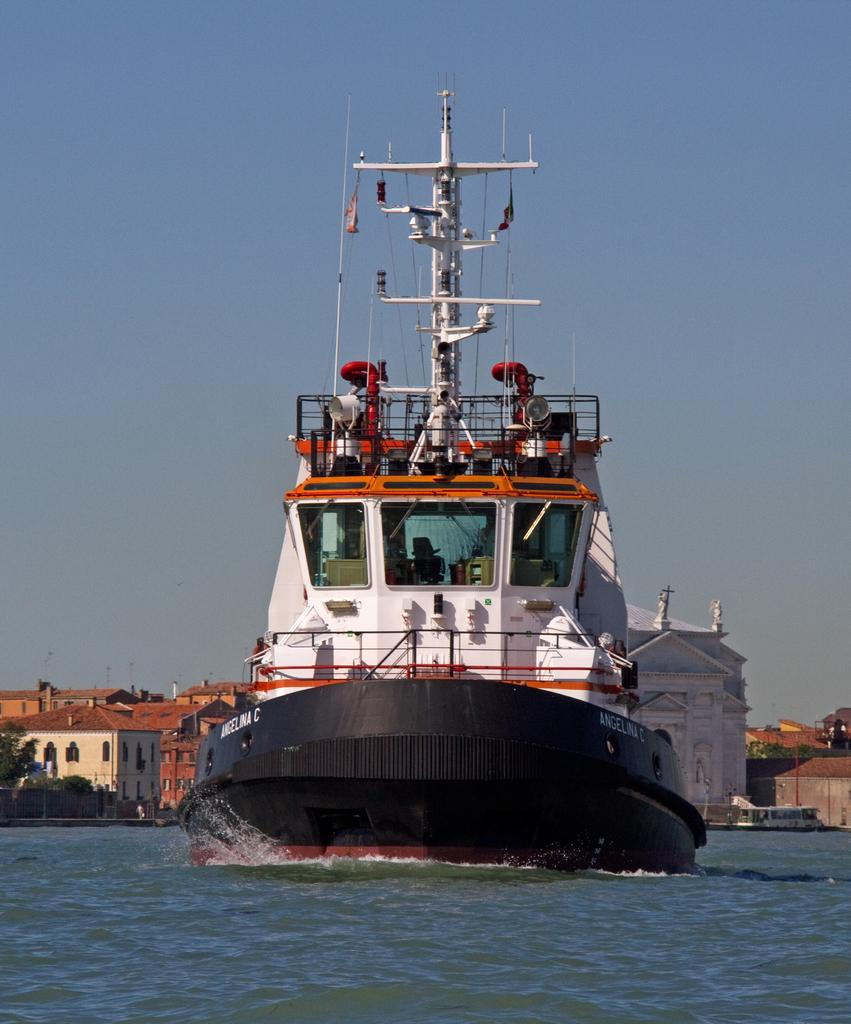What is the main subject of the image? The main subject of the image is a ship. Where is the ship located? The ship is in a water body. What can be seen in the background of the image? There are buildings, a fence, trees, and the sky visible in the background of the image. Can you describe the buildings in the background? The buildings have roofs and windows. What is the condition of the sky in the image? The sky appears cloudy in the image. What type of polish is being applied to the basketball in the image? There is no basketball or polish present in the image. Can you tell me how many boys are visible in the image? There are no boys visible in the image; it features a ship in a water body with buildings, a fence, trees, and a cloudy sky in the background. 